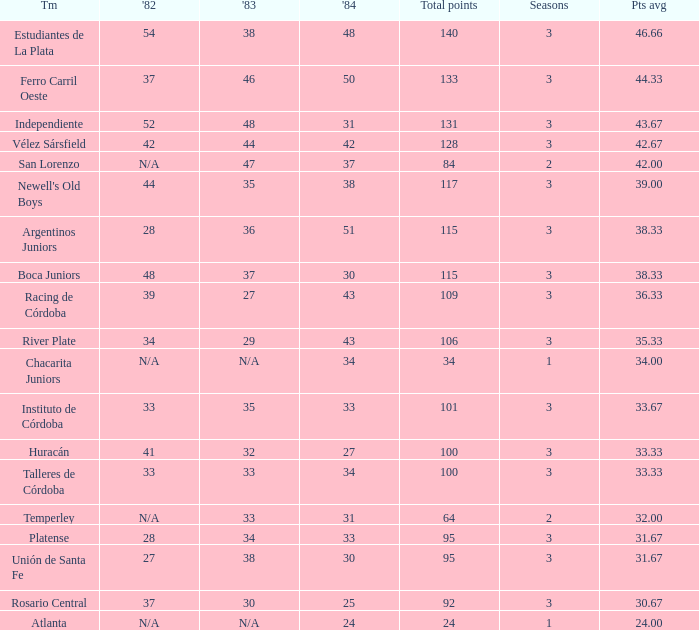What is the points total for the team with points average more than 34, 1984 score more than 37 and N/A in 1982? 0.0. 